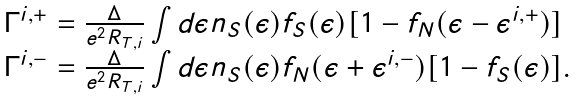<formula> <loc_0><loc_0><loc_500><loc_500>\begin{array} { l } \Gamma ^ { i , + } = \frac { \Delta } { e ^ { 2 } R _ { T , i } } \int d \epsilon n _ { S } ( \epsilon ) f _ { S } ( \epsilon ) [ 1 - f _ { N } ( \epsilon - \epsilon ^ { i , + } ) ] \\ \Gamma ^ { i , - } = \frac { \Delta } { e ^ { 2 } R _ { T , i } } \int d \epsilon n _ { S } ( \epsilon ) f _ { N } ( \epsilon + \epsilon ^ { i , - } ) [ 1 - f _ { S } ( \epsilon ) ] . \end{array}</formula> 